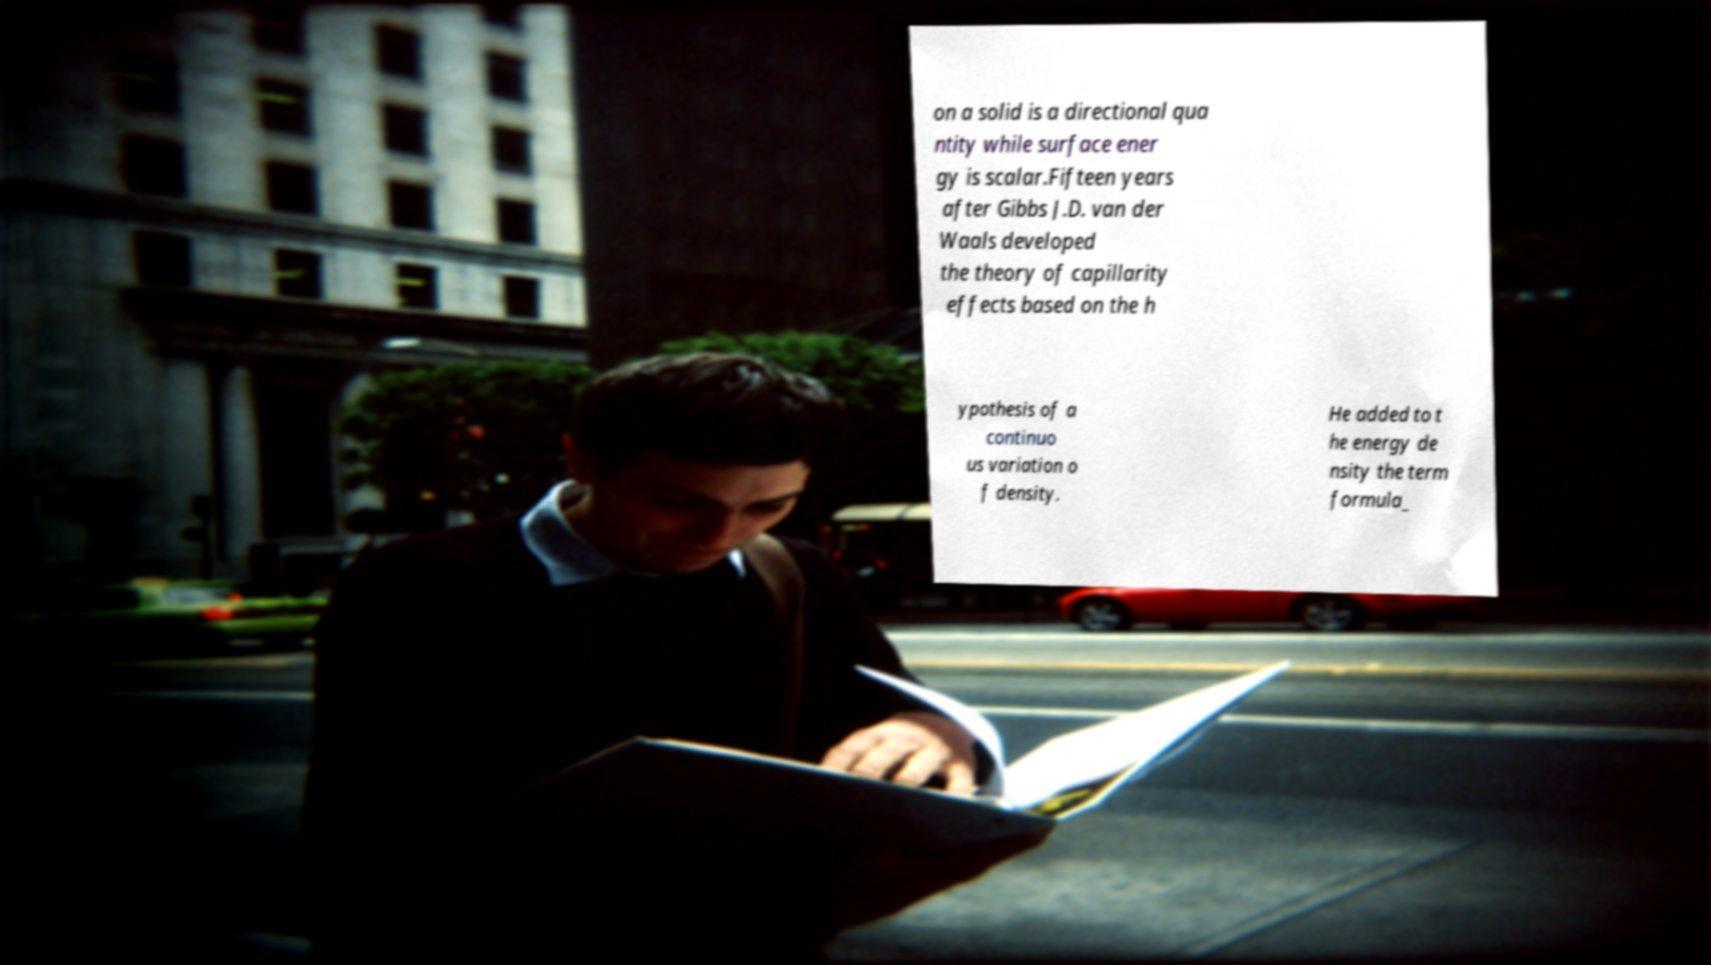Please read and relay the text visible in this image. What does it say? on a solid is a directional qua ntity while surface ener gy is scalar.Fifteen years after Gibbs J.D. van der Waals developed the theory of capillarity effects based on the h ypothesis of a continuo us variation o f density. He added to t he energy de nsity the term formula_ 